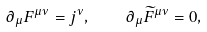<formula> <loc_0><loc_0><loc_500><loc_500>\partial _ { \mu } F ^ { \mu \nu } = j ^ { \nu } , \quad \partial _ { \mu } \widetilde { F } ^ { \mu \nu } = 0 ,</formula> 